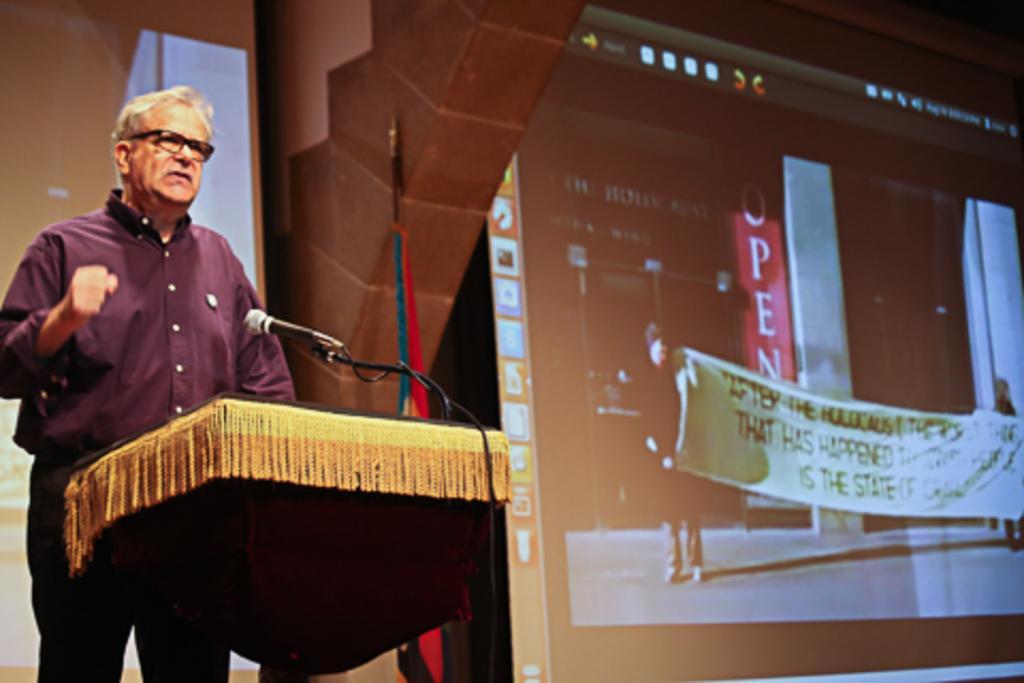Please provide a concise description of this image. On the left there is a person standing in front of the podium and speaking into a microphone. On the right there is a projector screen. In the background towards left there is a flag. 